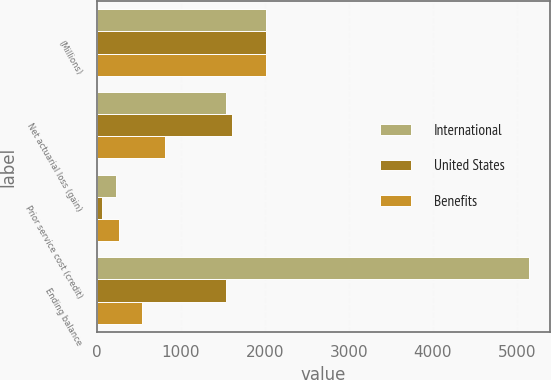Convert chart. <chart><loc_0><loc_0><loc_500><loc_500><stacked_bar_chart><ecel><fcel>(Millions)<fcel>Net actuarial loss (gain)<fcel>Prior service cost (credit)<fcel>Ending balance<nl><fcel>International<fcel>2015<fcel>1540<fcel>227<fcel>5139<nl><fcel>United States<fcel>2015<fcel>1610<fcel>68<fcel>1540<nl><fcel>Benefits<fcel>2015<fcel>815<fcel>270<fcel>545<nl></chart> 